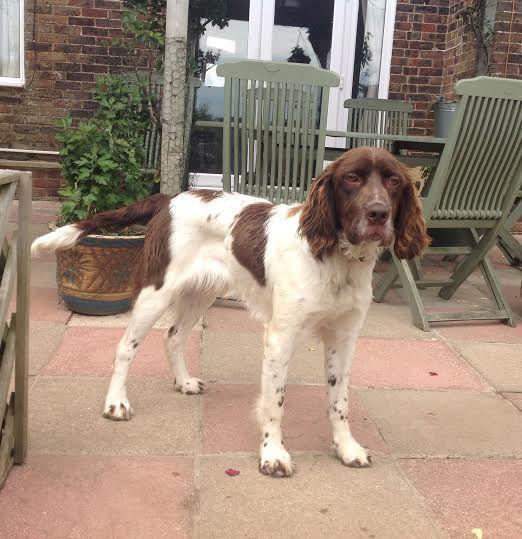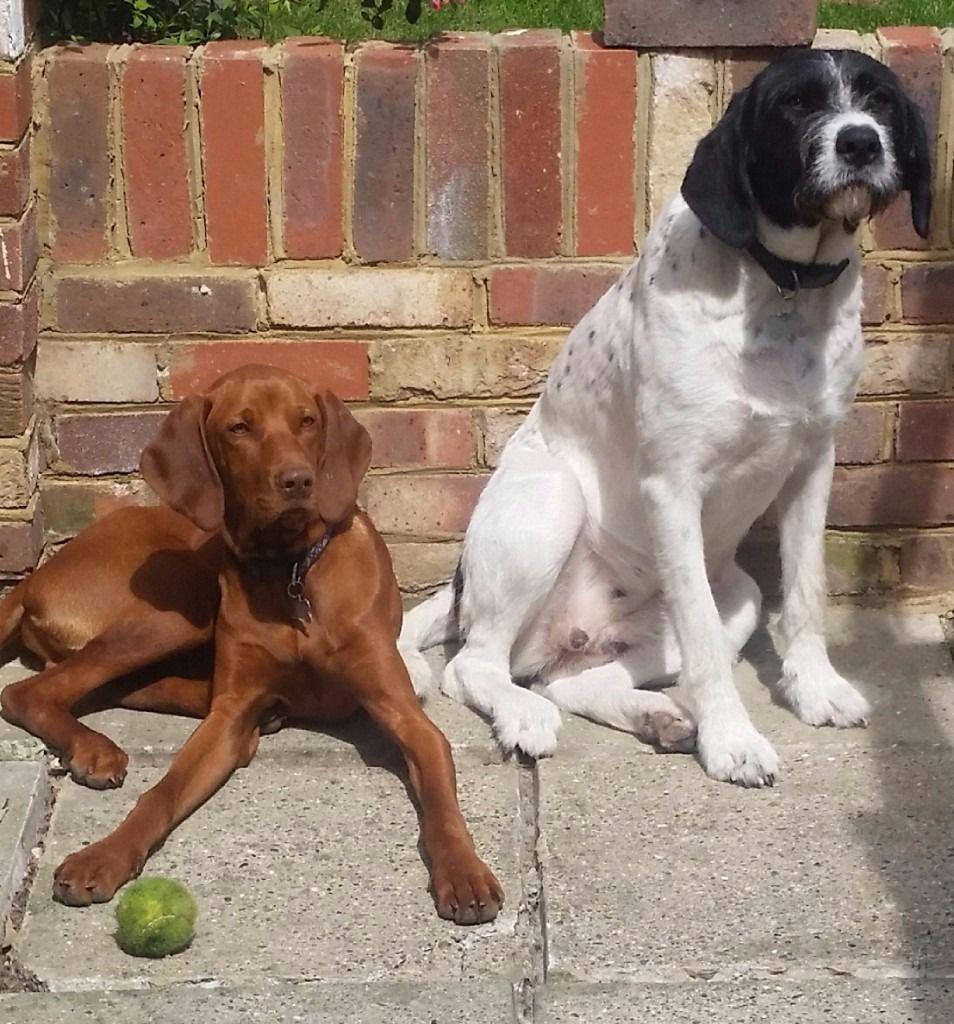The first image is the image on the left, the second image is the image on the right. For the images shown, is this caption "The combined images include one reddish-brown reclining dog and at least two spaniels with mostly white bodies and darker face markings." true? Answer yes or no. Yes. The first image is the image on the left, the second image is the image on the right. Examine the images to the left and right. Is the description "The right image contains exactly one dog." accurate? Answer yes or no. No. 